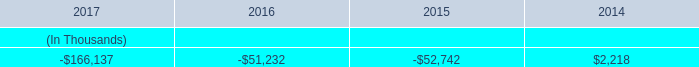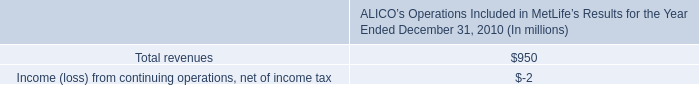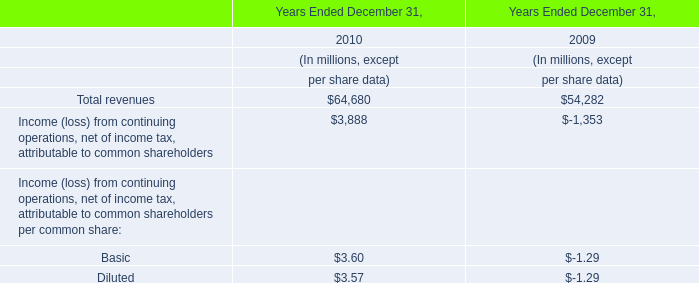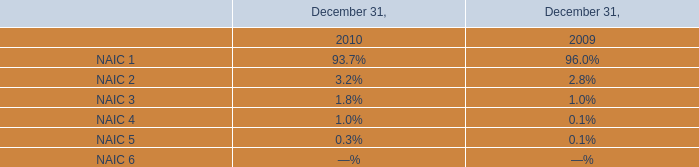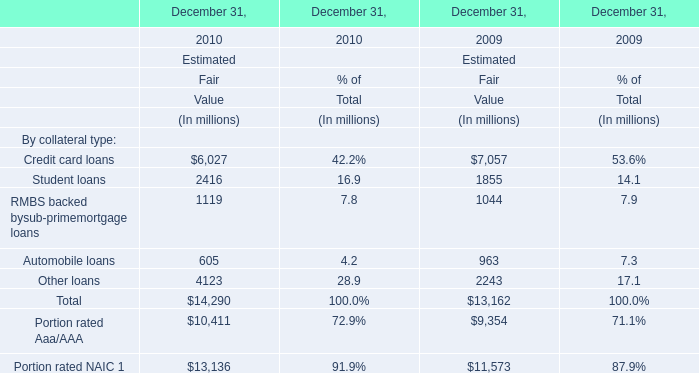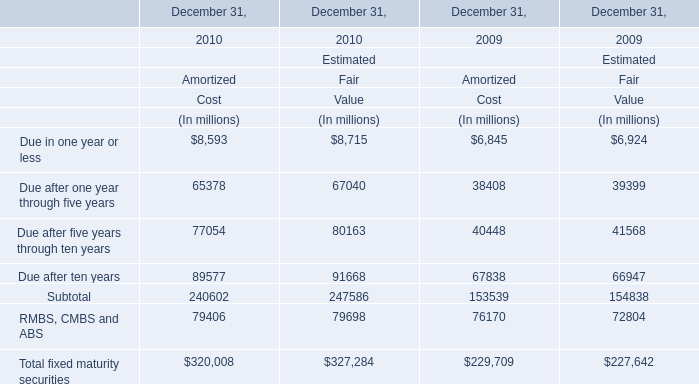What's the current increasing rate of RMBS, CMBS and ABS for Amortized? 
Computations: ((79406 - 76170) / 76170)
Answer: 0.04248. 